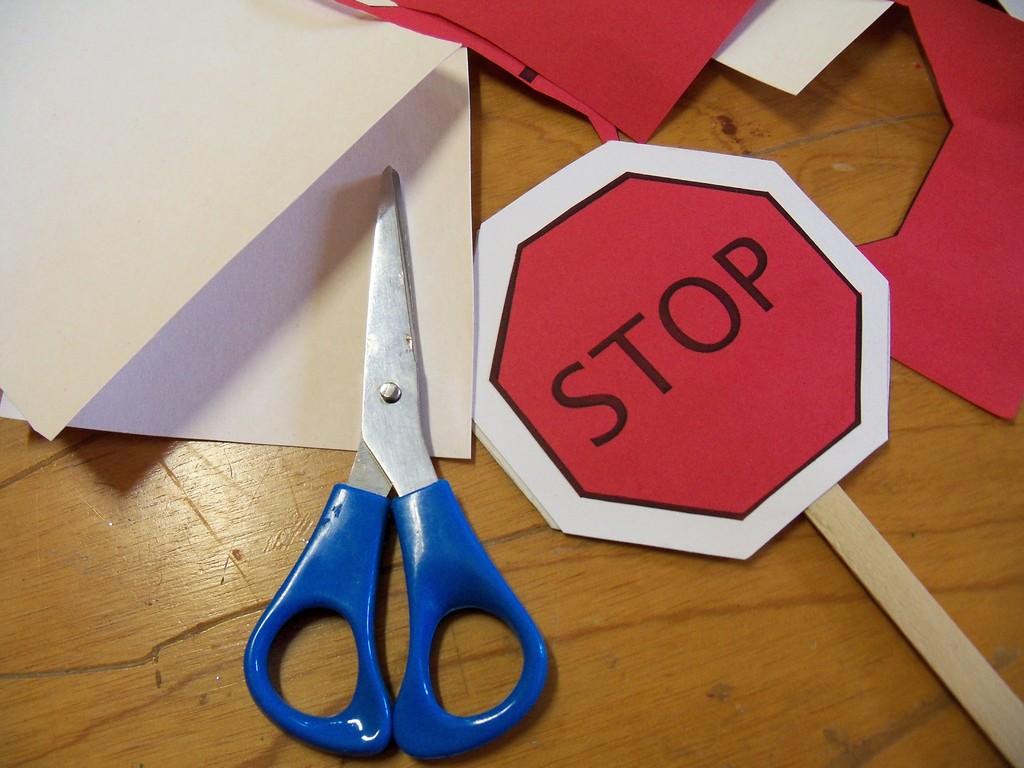What's the sign say?
Your answer should be compact. Stop. What color is that font written in?
Offer a terse response. Black. 